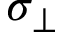Convert formula to latex. <formula><loc_0><loc_0><loc_500><loc_500>\sigma _ { \perp }</formula> 